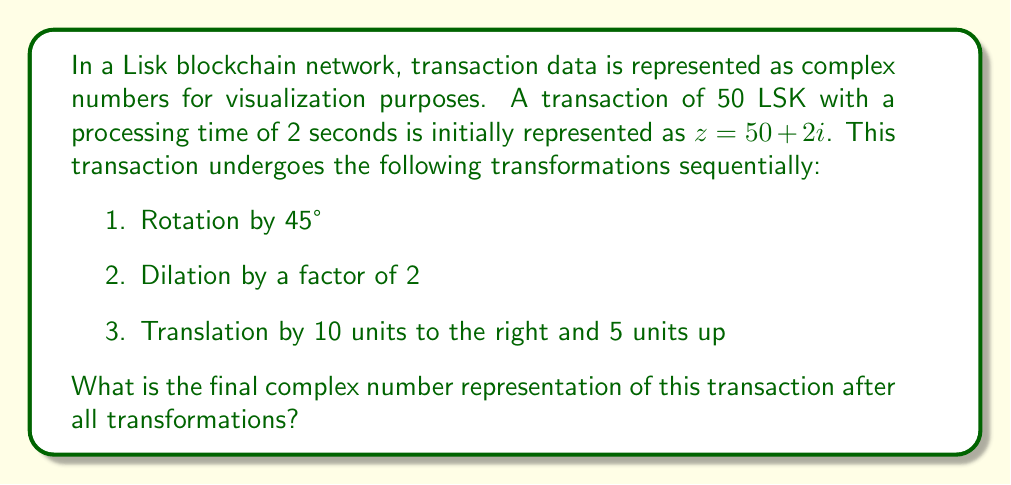Can you answer this question? Let's apply each transformation step-by-step:

1. Rotation by 45°:
   The rotation formula is $z' = z \cdot e^{i\theta}$, where $\theta = 45° = \frac{\pi}{4}$ radians.
   $z_1 = (50 + 2i) \cdot e^{i\frac{\pi}{4}} = (50 + 2i) \cdot (\frac{\sqrt{2}}{2} + \frac{\sqrt{2}}{2}i)$
   $z_1 = (50 \cdot \frac{\sqrt{2}}{2} - 2 \cdot \frac{\sqrt{2}}{2}) + (50 \cdot \frac{\sqrt{2}}{2} + 2 \cdot \frac{\sqrt{2}}{2})i$
   $z_1 = 25\sqrt{2} - \sqrt{2} + (25\sqrt{2} + \sqrt{2})i = 24\sqrt{2} + 26\sqrt{2}i$

2. Dilation by a factor of 2:
   Multiply the complex number by 2.
   $z_2 = 2 \cdot (24\sqrt{2} + 26\sqrt{2}i) = 48\sqrt{2} + 52\sqrt{2}i$

3. Translation by 10 units right and 5 units up:
   Add 10 to the real part and 5 to the imaginary part.
   $z_3 = (48\sqrt{2} + 10) + (52\sqrt{2} + 5)i$

Therefore, the final complex number representation is $z_3 = (48\sqrt{2} + 10) + (52\sqrt{2} + 5)i$.
Answer: $(48\sqrt{2} + 10) + (52\sqrt{2} + 5)i$ 